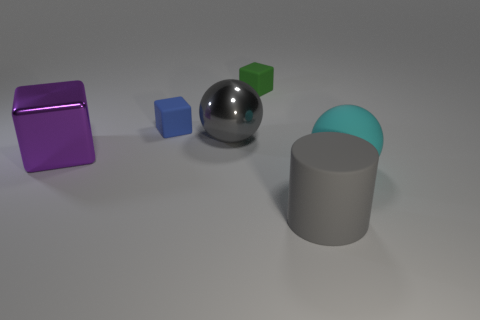Are there more purple cubes in front of the cyan rubber thing than purple objects on the right side of the large metal cube?
Provide a succinct answer. No. Is the matte cylinder the same size as the metallic cube?
Give a very brief answer. Yes. There is a big sphere that is to the left of the gray object that is in front of the cyan rubber object; what is its color?
Offer a terse response. Gray. The large metallic cube is what color?
Your answer should be compact. Purple. Are there any cylinders of the same color as the metallic sphere?
Keep it short and to the point. Yes. Do the large object that is in front of the cyan rubber thing and the large block have the same color?
Keep it short and to the point. No. What number of things are metallic things that are on the left side of the small blue cube or blue metallic objects?
Give a very brief answer. 1. Are there any big gray metal spheres behind the big gray metallic ball?
Offer a very short reply. No. There is a big sphere that is the same color as the rubber cylinder; what material is it?
Offer a very short reply. Metal. Do the ball in front of the purple shiny block and the gray ball have the same material?
Give a very brief answer. No. 